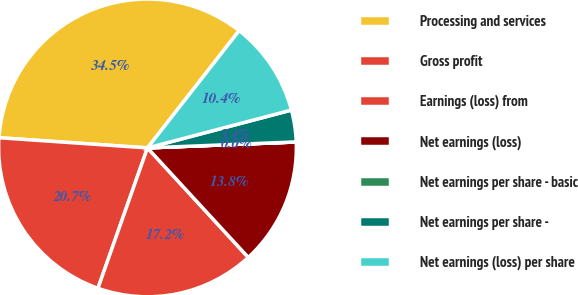Convert chart. <chart><loc_0><loc_0><loc_500><loc_500><pie_chart><fcel>Processing and services<fcel>Gross profit<fcel>Earnings (loss) from<fcel>Net earnings (loss)<fcel>Net earnings per share - basic<fcel>Net earnings per share -<fcel>Net earnings (loss) per share<nl><fcel>34.47%<fcel>20.69%<fcel>17.24%<fcel>13.79%<fcel>0.01%<fcel>3.45%<fcel>10.35%<nl></chart> 